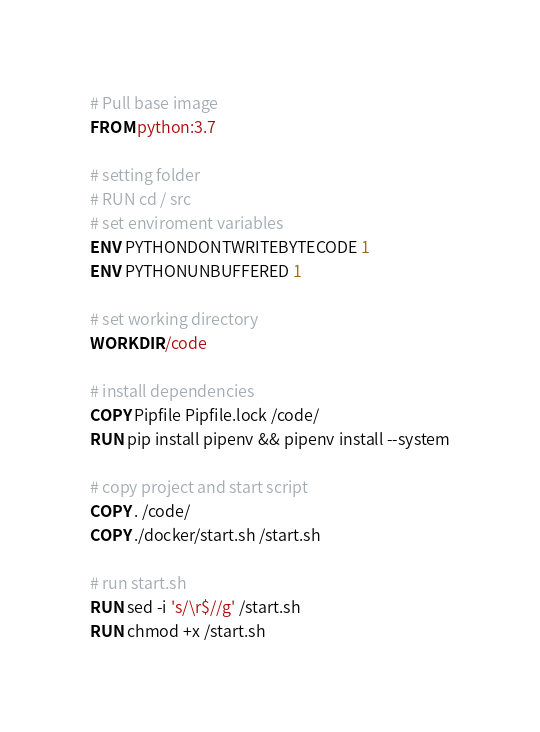Convert code to text. <code><loc_0><loc_0><loc_500><loc_500><_Dockerfile_># Pull base image
FROM python:3.7

# setting folder
# RUN cd / src
# set enviroment variables
ENV PYTHONDONTWRITEBYTECODE 1
ENV PYTHONUNBUFFERED 1

# set working directory
WORKDIR /code

# install dependencies
COPY Pipfile Pipfile.lock /code/
RUN pip install pipenv && pipenv install --system

# copy project and start script
COPY . /code/
COPY ./docker/start.sh /start.sh

# run start.sh
RUN sed -i 's/\r$//g' /start.sh
RUN chmod +x /start.sh
</code> 